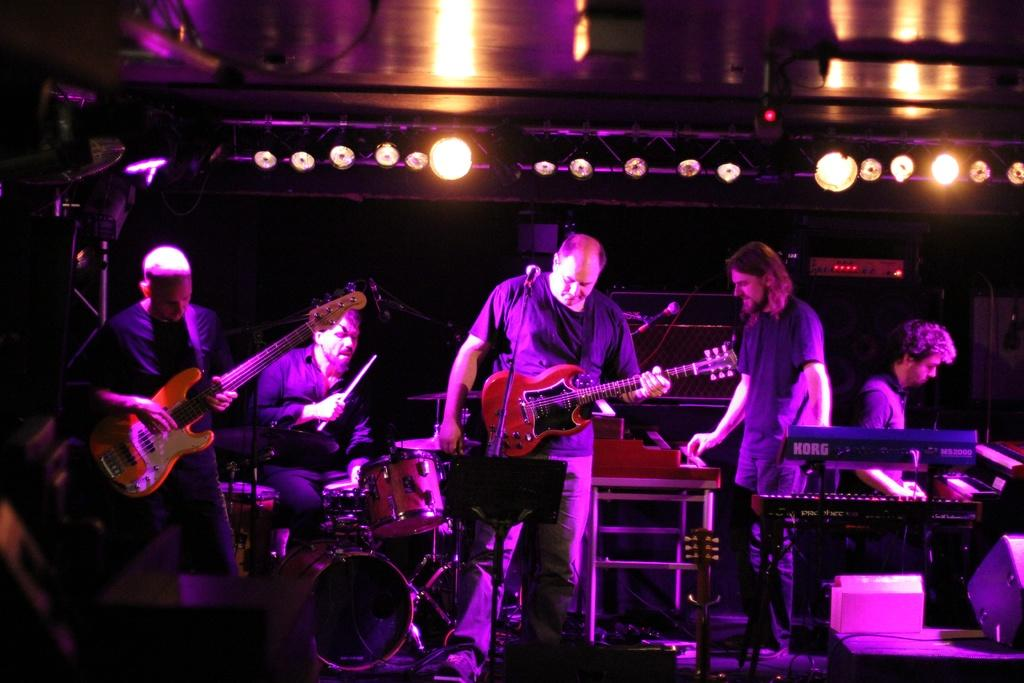What are the people in the middle of the image doing? The people are playing musical instruments. What structure is present in the middle of the image? There is a roof in the middle of the image. What can be seen in the image that provides illumination? There are lights present in the image. How many jewels are visible on the back of the person playing the guitar in the image? There are no jewels visible on the back of the person playing the guitar in the image. 